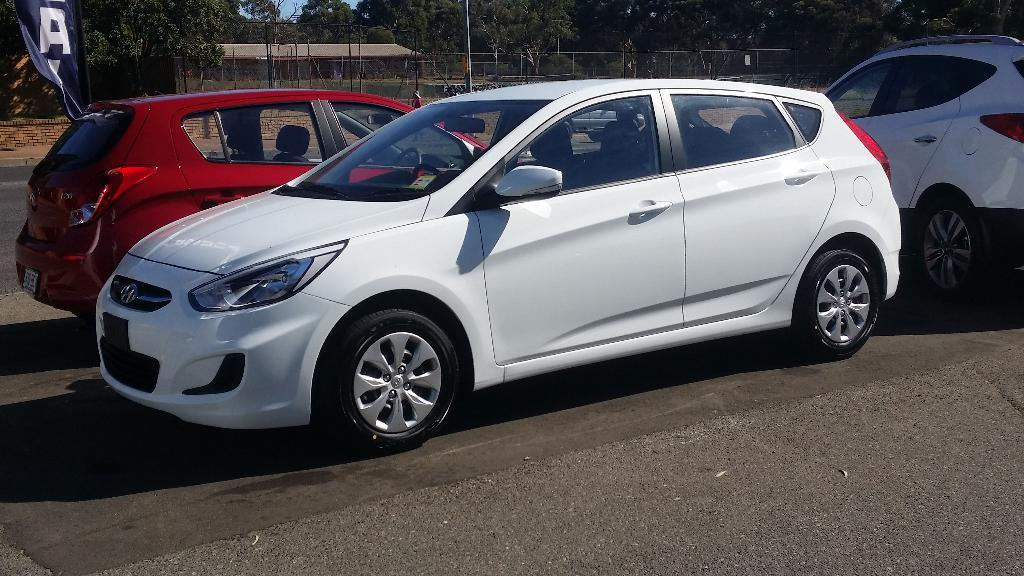What can be seen on the road in the image? There are cars on the road in the image. What is visible in the background of the image? In the background of the image, there is a flag, a fence, metal rods, trees, and a house. Can you describe the fence in the background? The fence in the background is made of metal rods. How many toes can be seen on the parent in the image? There is no parent or toes present in the image. What type of rest can be seen in the image? There is no rest visible in the image; it features cars on the road and various background elements. 